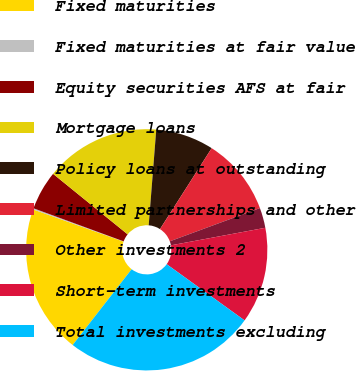<chart> <loc_0><loc_0><loc_500><loc_500><pie_chart><fcel>Fixed maturities<fcel>Fixed maturities at fair value<fcel>Equity securities AFS at fair<fcel>Mortgage loans<fcel>Policy loans at outstanding<fcel>Limited partnerships and other<fcel>Other investments 2<fcel>Short-term investments<fcel>Total investments excluding<nl><fcel>19.91%<fcel>0.16%<fcel>5.25%<fcel>15.41%<fcel>7.79%<fcel>10.33%<fcel>2.7%<fcel>12.87%<fcel>25.58%<nl></chart> 